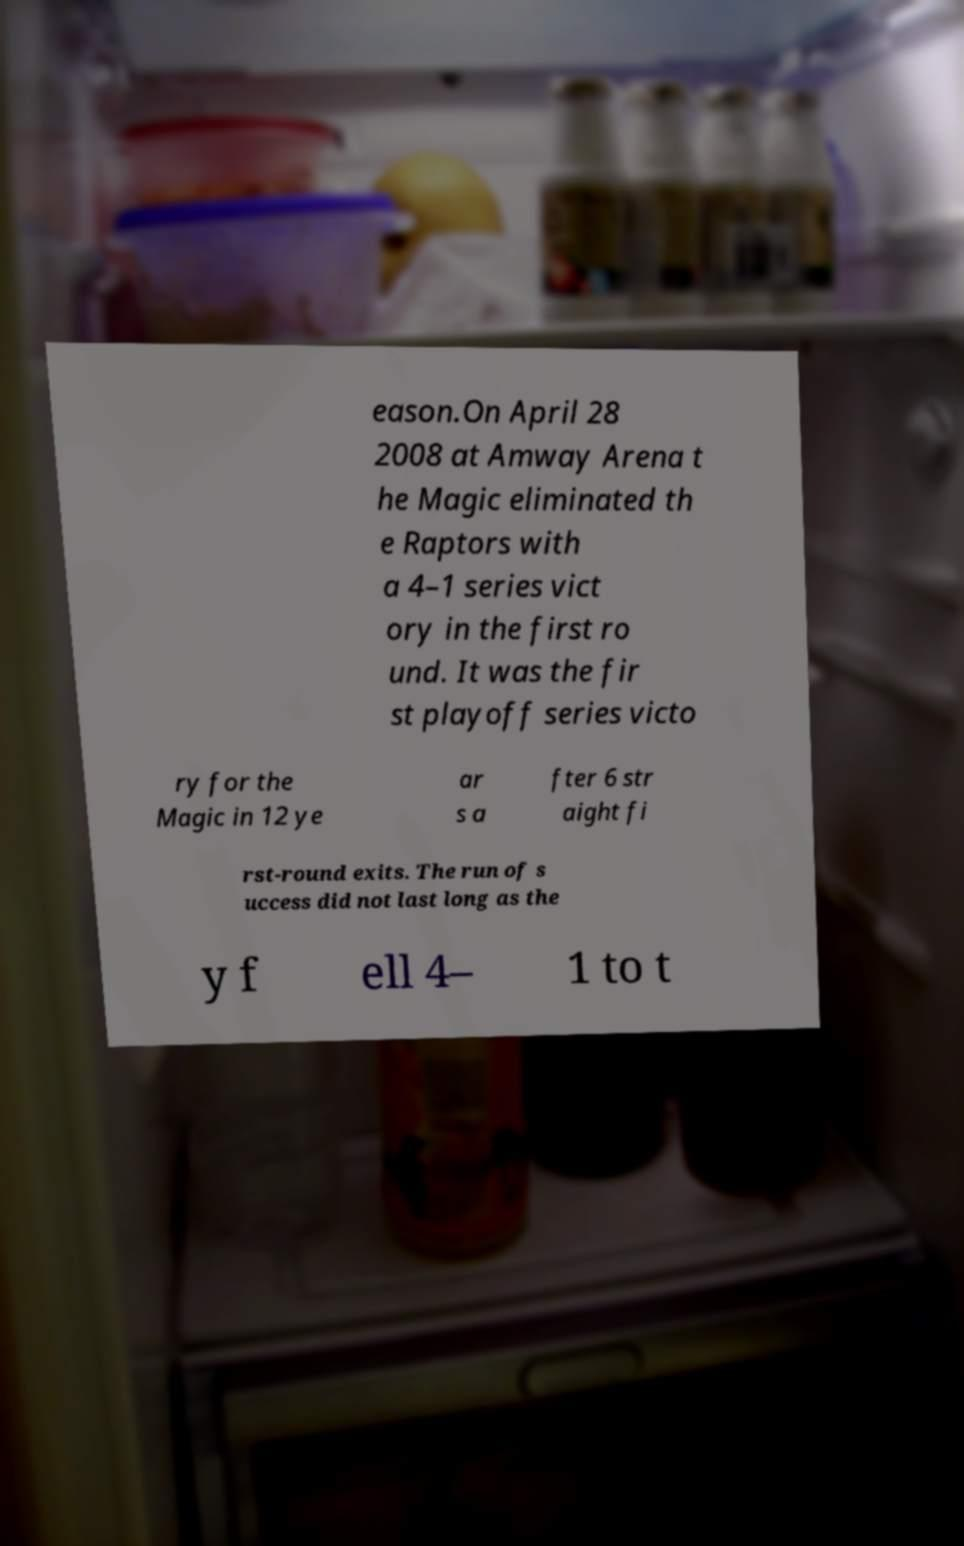I need the written content from this picture converted into text. Can you do that? eason.On April 28 2008 at Amway Arena t he Magic eliminated th e Raptors with a 4–1 series vict ory in the first ro und. It was the fir st playoff series victo ry for the Magic in 12 ye ar s a fter 6 str aight fi rst-round exits. The run of s uccess did not last long as the y f ell 4– 1 to t 